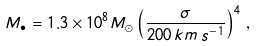Convert formula to latex. <formula><loc_0><loc_0><loc_500><loc_500>M _ { \bullet } = 1 . 3 \times 1 0 ^ { 8 } M _ { \odot } \left ( \frac { \sigma } { 2 0 0 \, k m \, s ^ { - 1 } } \right ) ^ { 4 } \, ,</formula> 